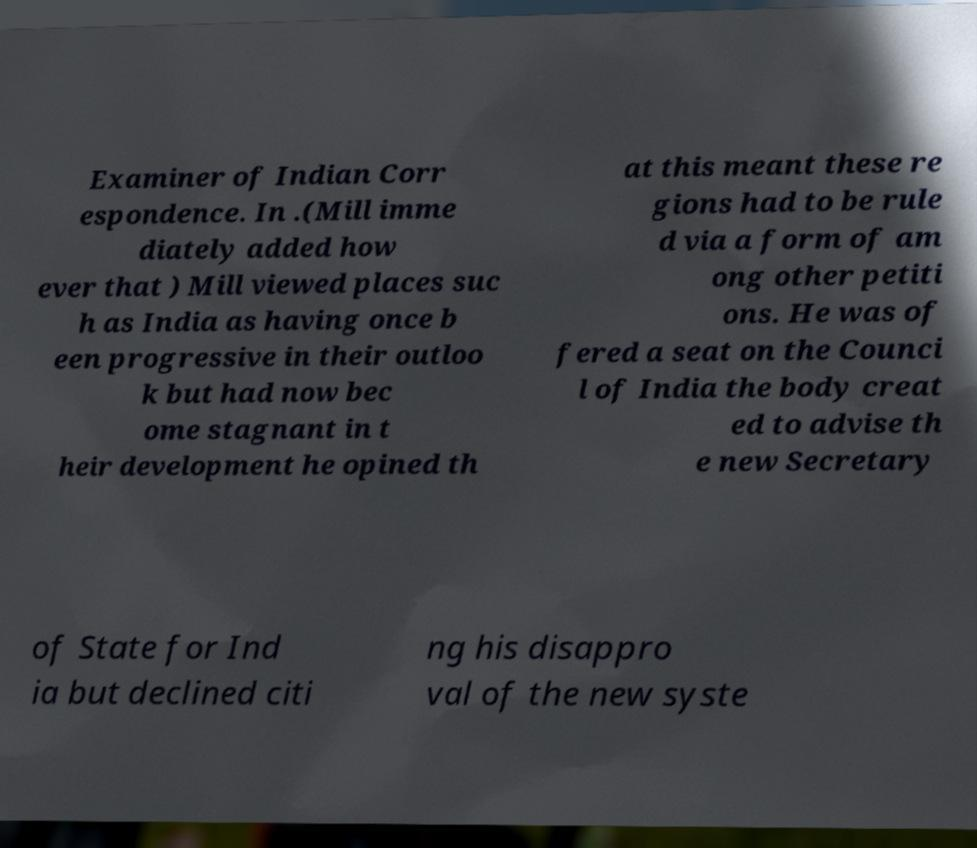Can you accurately transcribe the text from the provided image for me? Examiner of Indian Corr espondence. In .(Mill imme diately added how ever that ) Mill viewed places suc h as India as having once b een progressive in their outloo k but had now bec ome stagnant in t heir development he opined th at this meant these re gions had to be rule d via a form of am ong other petiti ons. He was of fered a seat on the Counci l of India the body creat ed to advise th e new Secretary of State for Ind ia but declined citi ng his disappro val of the new syste 